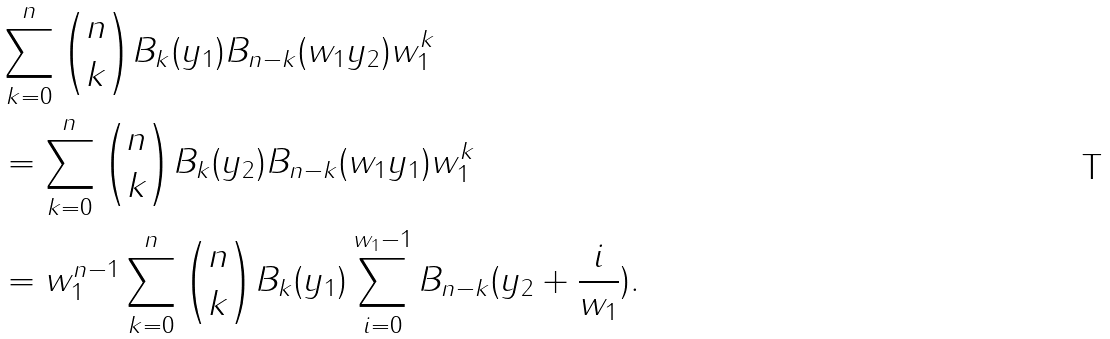Convert formula to latex. <formula><loc_0><loc_0><loc_500><loc_500>& \sum _ { k = 0 } ^ { n } \binom { n } { k } B _ { k } ( y _ { 1 } ) B _ { n - k } ( w _ { 1 } y _ { 2 } ) w _ { 1 } ^ { k } \\ & = \sum _ { k = 0 } ^ { n } \binom { n } { k } B _ { k } ( y _ { 2 } ) B _ { n - k } ( w _ { 1 } y _ { 1 } ) w _ { 1 } ^ { k } \\ & = w _ { 1 } ^ { n - 1 } \sum _ { k = 0 } ^ { n } \binom { n } { k } B _ { k } ( y _ { 1 } ) \sum _ { i = 0 } ^ { w _ { 1 } - 1 } B _ { n - k } ( y _ { 2 } + \frac { i } { w _ { 1 } } ) . \\</formula> 